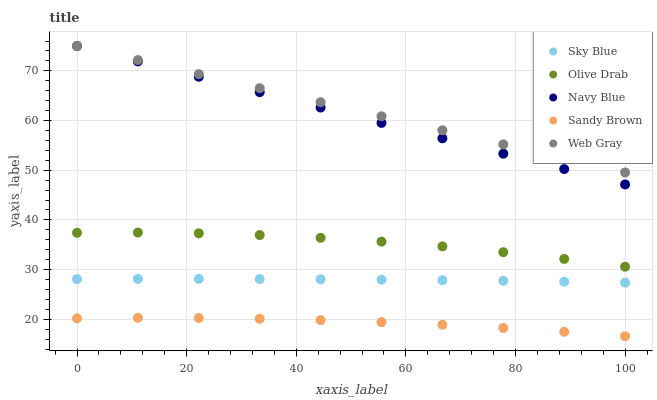Does Sandy Brown have the minimum area under the curve?
Answer yes or no. Yes. Does Web Gray have the maximum area under the curve?
Answer yes or no. Yes. Does Web Gray have the minimum area under the curve?
Answer yes or no. No. Does Sandy Brown have the maximum area under the curve?
Answer yes or no. No. Is Web Gray the smoothest?
Answer yes or no. Yes. Is Olive Drab the roughest?
Answer yes or no. Yes. Is Sandy Brown the smoothest?
Answer yes or no. No. Is Sandy Brown the roughest?
Answer yes or no. No. Does Sandy Brown have the lowest value?
Answer yes or no. Yes. Does Web Gray have the lowest value?
Answer yes or no. No. Does Navy Blue have the highest value?
Answer yes or no. Yes. Does Sandy Brown have the highest value?
Answer yes or no. No. Is Sky Blue less than Olive Drab?
Answer yes or no. Yes. Is Navy Blue greater than Sky Blue?
Answer yes or no. Yes. Does Web Gray intersect Navy Blue?
Answer yes or no. Yes. Is Web Gray less than Navy Blue?
Answer yes or no. No. Is Web Gray greater than Navy Blue?
Answer yes or no. No. Does Sky Blue intersect Olive Drab?
Answer yes or no. No. 